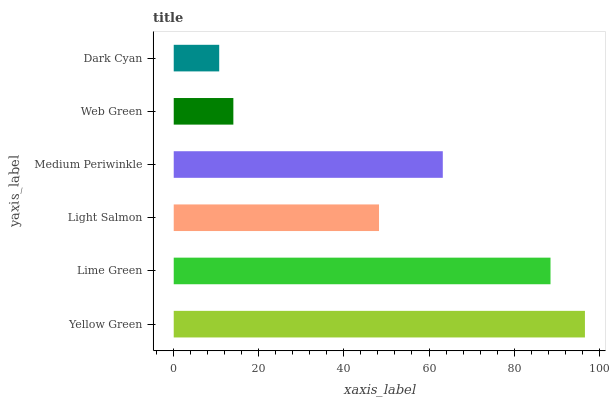Is Dark Cyan the minimum?
Answer yes or no. Yes. Is Yellow Green the maximum?
Answer yes or no. Yes. Is Lime Green the minimum?
Answer yes or no. No. Is Lime Green the maximum?
Answer yes or no. No. Is Yellow Green greater than Lime Green?
Answer yes or no. Yes. Is Lime Green less than Yellow Green?
Answer yes or no. Yes. Is Lime Green greater than Yellow Green?
Answer yes or no. No. Is Yellow Green less than Lime Green?
Answer yes or no. No. Is Medium Periwinkle the high median?
Answer yes or no. Yes. Is Light Salmon the low median?
Answer yes or no. Yes. Is Lime Green the high median?
Answer yes or no. No. Is Web Green the low median?
Answer yes or no. No. 